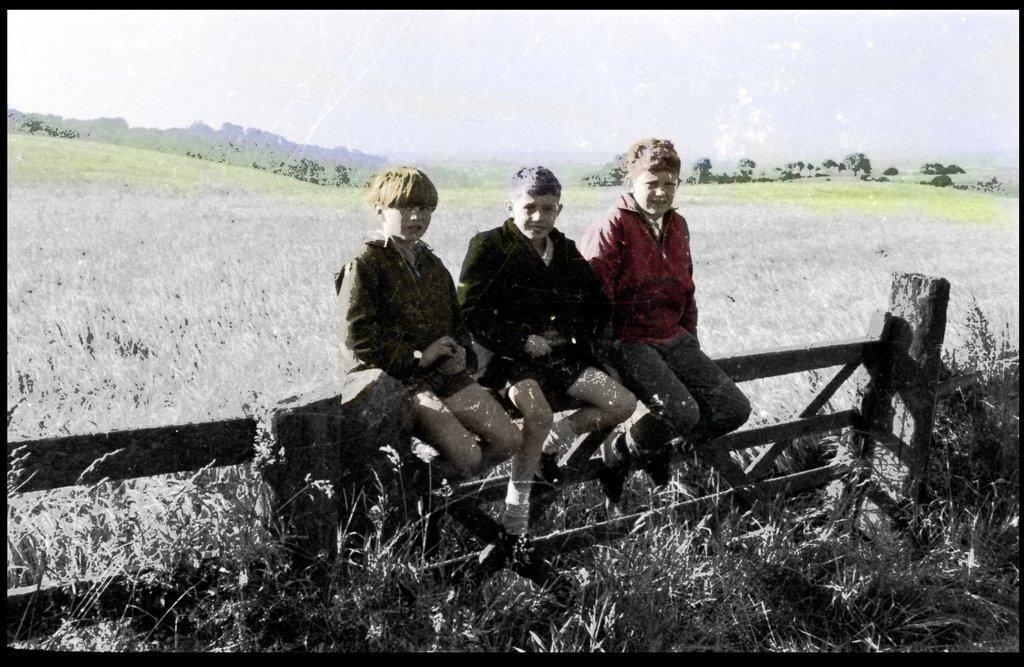In one or two sentences, can you explain what this image depicts? In the center of the image we can see three persons are sitting on a fence and they are in different costumes. In the background, we can see the sky, trees and grass. And we can see the black colored border around the image. 